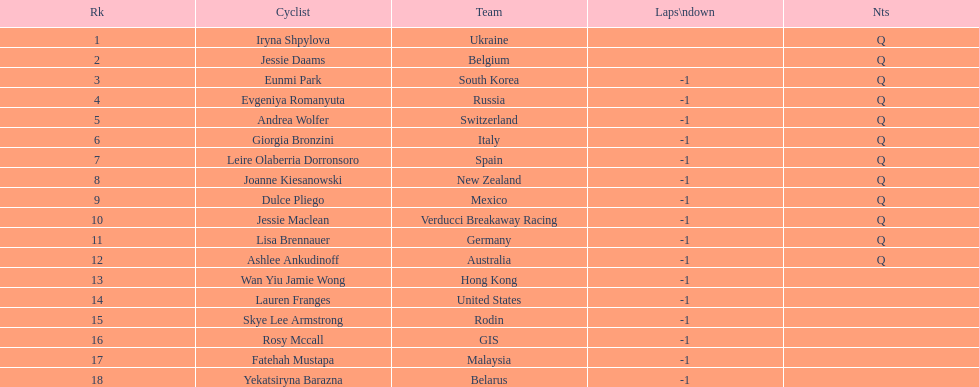Who was the opponent that concluded before jessie maclean? Dulce Pliego. 